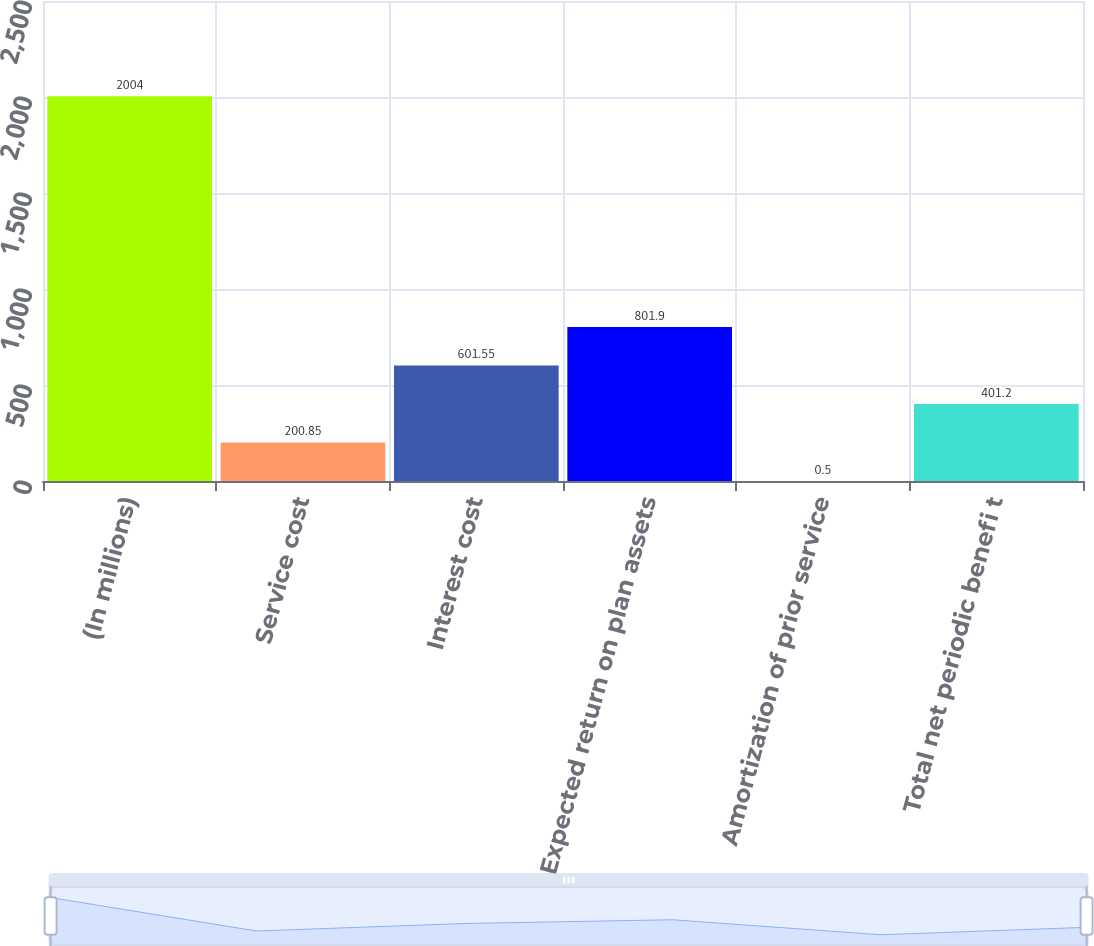<chart> <loc_0><loc_0><loc_500><loc_500><bar_chart><fcel>(In millions)<fcel>Service cost<fcel>Interest cost<fcel>Expected return on plan assets<fcel>Amortization of prior service<fcel>Total net periodic benefi t<nl><fcel>2004<fcel>200.85<fcel>601.55<fcel>801.9<fcel>0.5<fcel>401.2<nl></chart> 